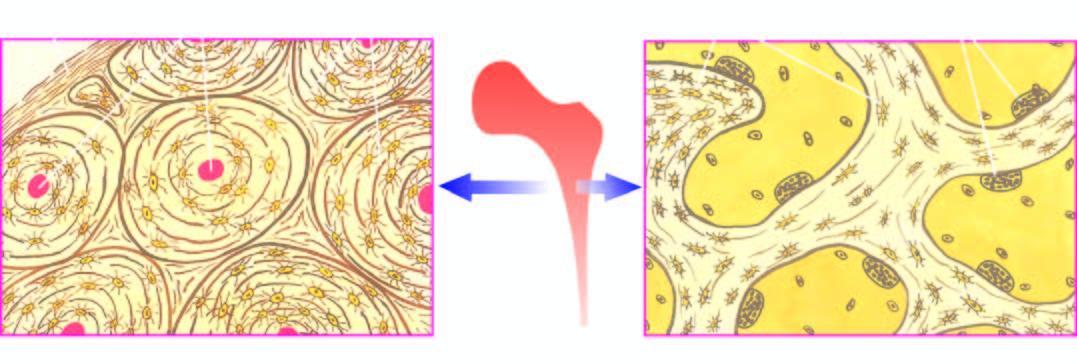what does the trabecular bone forming the marrow space show at the margins?
Answer the question using a single word or phrase. Trabeculae with osteoclastic activity 